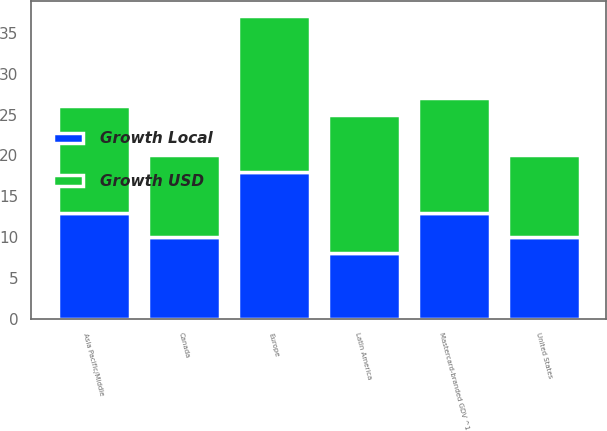Convert chart. <chart><loc_0><loc_0><loc_500><loc_500><stacked_bar_chart><ecel><fcel>Mastercard-branded GDV ^1<fcel>Asia Pacific/Middle<fcel>Canada<fcel>Europe<fcel>Latin America<fcel>United States<nl><fcel>Growth Local<fcel>13<fcel>13<fcel>10<fcel>18<fcel>8<fcel>10<nl><fcel>Growth USD<fcel>14<fcel>13<fcel>10<fcel>19<fcel>17<fcel>10<nl></chart> 